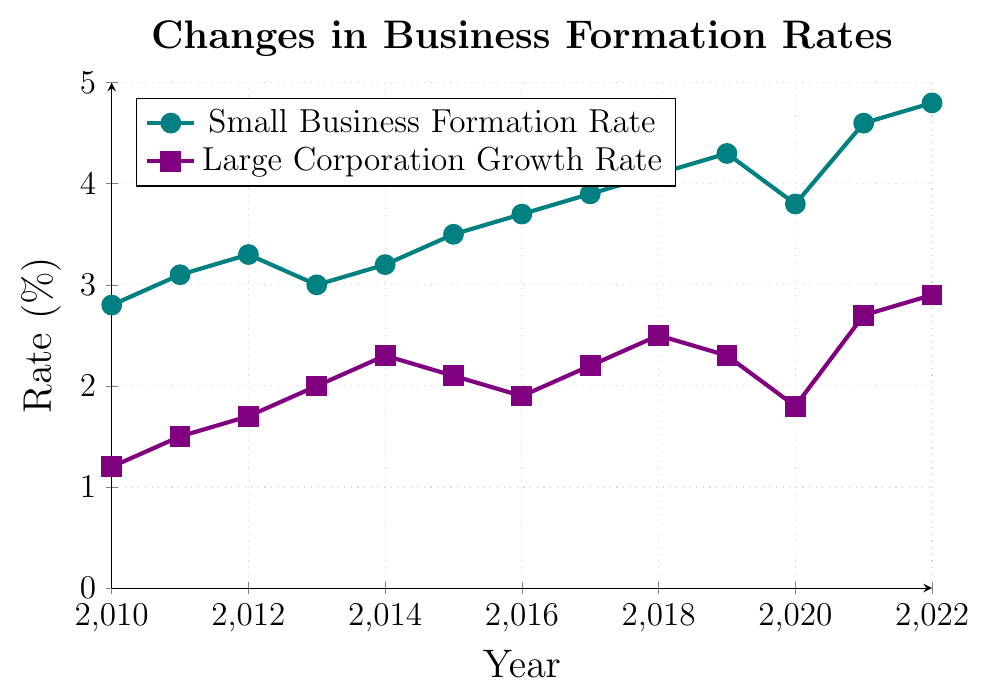What was the small business formation rate in 2013? The rate for small business formation in 2013 can be directly read from the chart where the data point plots.
Answer: 3.0% What is the difference between the small business formation rate and large corporation growth rate in 2022? To find the difference, locate both rates for 2022 on the chart: Small Business Formation Rate is 4.8% and Large Corporation Growth Rate is 2.9%. Subtract the latter from the former: 4.8% - 2.9% = 1.9%.
Answer: 1.9% In which year did the large corporation growth rate have the maximum value? Survey the chart to identify the highest point on the Large Corporation Growth Rate line, which peaks in 2022 at 2.9%.
Answer: 2022 How much did the small business formation rate increase from 2010 to 2022? Identify the values for 2010 (2.8%) and 2022 (4.8%) from the chart. Calculate the increase by subtracting the 2010 rate from the 2022 rate: 4.8% - 2.8% = 2.0%.
Answer: 2.0% Which year experienced a decrease in the small business formation rate from the previous year? Observe the chart for downward trends in the Small Business Formation Rate: The decline occurs between 2012 (3.3%) and 2013 (3.0%).
Answer: 2013 Compare the growth rates of large corporations in 2015 and 2016. Which one was higher? From the chart, find the growth rates for 2015 (2.1%) and 2016 (1.9%). Compare these two values: 2.1% is higher than 1.9%.
Answer: 2015 Throughout the entire period, did the small business formation rate always stay above the large corporation growth rate? Examine the chart to compare both lines continuously from 2010 to 2022; the Small Business Formation Rate is always above the Large Corporation Growth Rate in all given years.
Answer: Yes What is the average small business formation rate for the years 2010 through 2022? Sum all the individual annual rates (2.8 + 3.1 + 3.3 + 3.0 + 3.2 + 3.5 + 3.7 + 3.9 + 4.1 + 4.3 + 3.8 + 4.6 + 4.8), then divide by the number of years (13). Total is 48.1%, average is 48.1 / 13 = 3.7%.
Answer: 3.7% Which rate showed greater volatility over the period, small business formation rates or large corporation growth rates? Evaluate the fluctuation of both lines' values over the chart period: Small Business Formation Rate varies from 2.8% to 4.8%, while Large Corporation Growth Rate varies from 1.2% to 2.9%. The range for small businesses (4.8 - 2.8 = 2.0%) is larger than for large corporations (2.9 - 1.2 = 1.7%), indicating greater volatility.
Answer: Small Business Formation Rate By how much did the large corporation growth rate change from 2020 to 2021? Locate the rates for 2020 (1.8%) and 2021 (2.7%) on the chart. Calculate the change by finding their difference: 2.7% - 1.8% = 0.9%.
Answer: 0.9% 